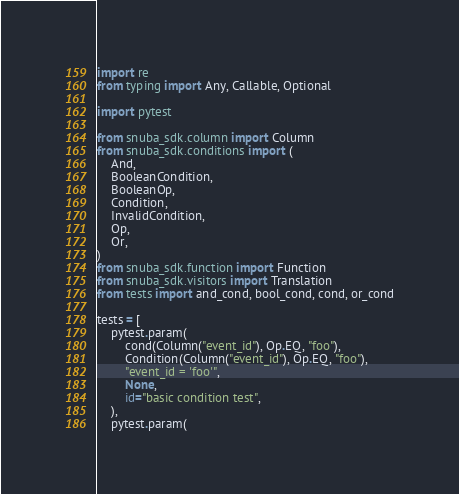Convert code to text. <code><loc_0><loc_0><loc_500><loc_500><_Python_>import re
from typing import Any, Callable, Optional

import pytest

from snuba_sdk.column import Column
from snuba_sdk.conditions import (
    And,
    BooleanCondition,
    BooleanOp,
    Condition,
    InvalidCondition,
    Op,
    Or,
)
from snuba_sdk.function import Function
from snuba_sdk.visitors import Translation
from tests import and_cond, bool_cond, cond, or_cond

tests = [
    pytest.param(
        cond(Column("event_id"), Op.EQ, "foo"),
        Condition(Column("event_id"), Op.EQ, "foo"),
        "event_id = 'foo'",
        None,
        id="basic condition test",
    ),
    pytest.param(</code> 